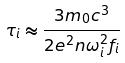Convert formula to latex. <formula><loc_0><loc_0><loc_500><loc_500>\tau _ { i } \approx \frac { 3 m _ { 0 } c ^ { 3 } } { 2 e ^ { 2 } n \omega _ { i } ^ { 2 } f _ { i } }</formula> 